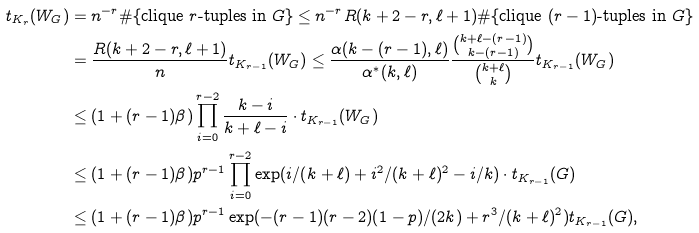<formula> <loc_0><loc_0><loc_500><loc_500>t _ { K _ { r } } ( W _ { G } ) & = n ^ { - r } \# \{ \text {clique } r \text {-tuples in } G \} \leq n ^ { - r } R ( k + 2 - r , \ell + 1 ) \# \{ \text {clique } ( r - 1 ) \text {-tuples in } G \} \\ & = \frac { R ( k + 2 - r , \ell + 1 ) } { n } t _ { K _ { r - 1 } } ( W _ { G } ) \leq \frac { \alpha ( k - ( r - 1 ) , \ell ) } { \alpha ^ { \ast } ( k , \ell ) } \frac { \binom { k + \ell - ( r - 1 ) } { k - ( r - 1 ) } } { \binom { k + \ell } { k } } t _ { K _ { r - 1 } } ( W _ { G } ) \\ & \leq ( 1 + ( r - 1 ) \beta ) \prod _ { i = 0 } ^ { r - 2 } \frac { k - i } { k + \ell - i } \cdot t _ { K _ { r - 1 } } ( W _ { G } ) \\ & \leq ( 1 + ( r - 1 ) \beta ) p ^ { r - 1 } \prod _ { i = 0 } ^ { r - 2 } \exp ( i / ( k + \ell ) + i ^ { 2 } / ( k + \ell ) ^ { 2 } - i / k ) \cdot t _ { K _ { r - 1 } } ( G ) \\ & \leq ( 1 + ( r - 1 ) \beta ) p ^ { r - 1 } \exp ( - ( r - 1 ) ( r - 2 ) ( 1 - p ) / ( 2 k ) + r ^ { 3 } / ( k + \ell ) ^ { 2 } ) t _ { K _ { r - 1 } } ( G ) ,</formula> 